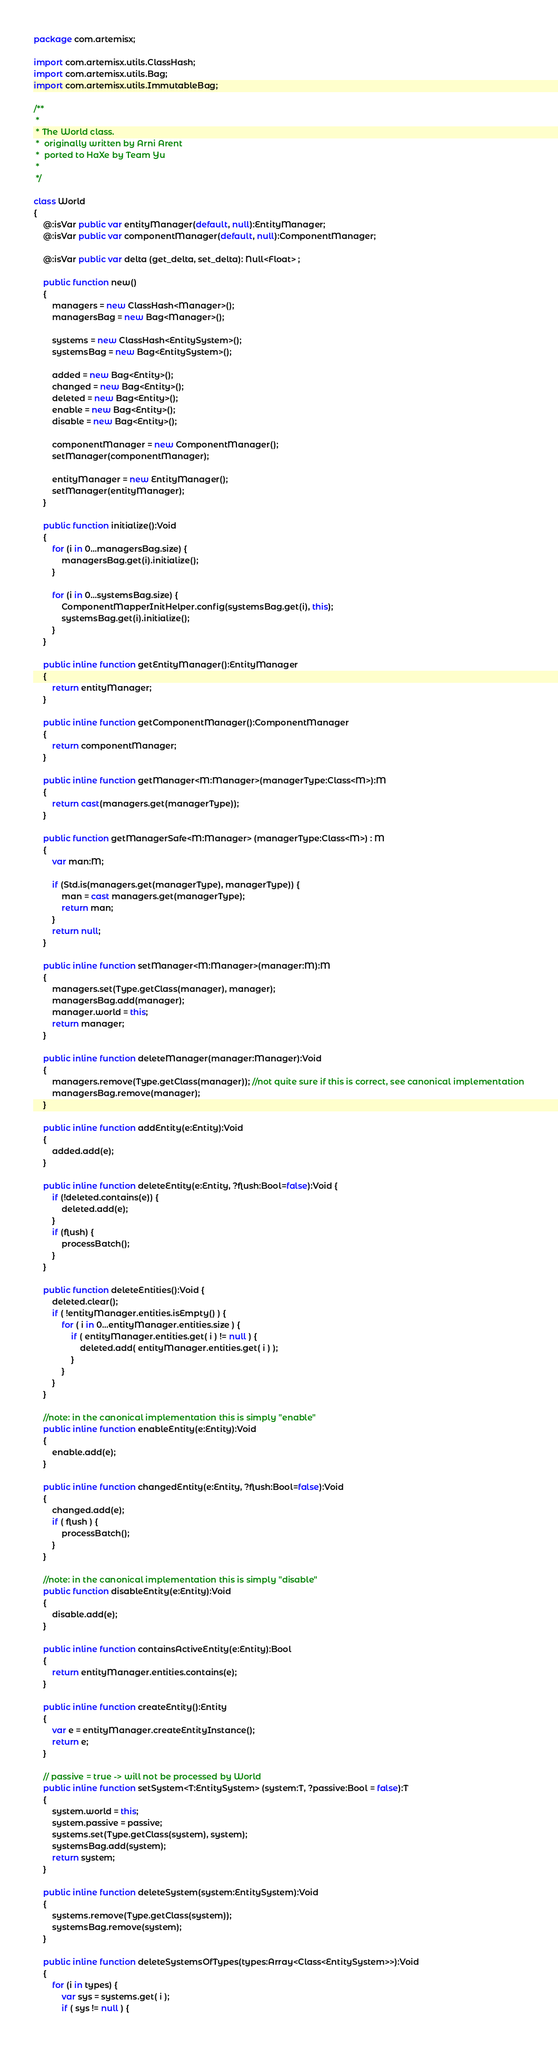Convert code to text. <code><loc_0><loc_0><loc_500><loc_500><_Haxe_>package com.artemisx;

import com.artemisx.utils.ClassHash;
import com.artemisx.utils.Bag;
import com.artemisx.utils.ImmutableBag;

/**
 *
 * The World class.
 *  originally written by Arni Arent
 *  ported to HaXe by Team Yu
 *
 */

class World
{
    @:isVar public var entityManager(default, null):EntityManager;
    @:isVar public var componentManager(default, null):ComponentManager;

    @:isVar public var delta (get_delta, set_delta): Null<Float> ;

    public function new()
    {
        managers = new ClassHash<Manager>();
        managersBag = new Bag<Manager>();

        systems = new ClassHash<EntitySystem>();
        systemsBag = new Bag<EntitySystem>();

        added = new Bag<Entity>();
        changed = new Bag<Entity>();
        deleted = new Bag<Entity>();
        enable = new Bag<Entity>();
        disable = new Bag<Entity>();

        componentManager = new ComponentManager();
        setManager(componentManager);

        entityManager = new EntityManager();
        setManager(entityManager);
    }

    public function initialize():Void
    {
        for (i in 0...managersBag.size) {
            managersBag.get(i).initialize();
        }

        for (i in 0...systemsBag.size) {
            ComponentMapperInitHelper.config(systemsBag.get(i), this);
            systemsBag.get(i).initialize();
        }
    }

    public inline function getEntityManager():EntityManager
    {
        return entityManager;
    }

    public inline function getComponentManager():ComponentManager
    {
        return componentManager;
    }

    public inline function getManager<M:Manager>(managerType:Class<M>):M
    {
        return cast(managers.get(managerType));
    }

    public function getManagerSafe<M:Manager> (managerType:Class<M>) : M
    {
        var man:M;

        if (Std.is(managers.get(managerType), managerType)) {
            man = cast managers.get(managerType);
            return man;
        }
        return null;
    }

    public inline function setManager<M:Manager>(manager:M):M
    {
        managers.set(Type.getClass(manager), manager);
        managersBag.add(manager);
        manager.world = this;
        return manager;
    }

    public inline function deleteManager(manager:Manager):Void
    {
        managers.remove(Type.getClass(manager)); //not quite sure if this is correct, see canonical implementation
        managersBag.remove(manager);
    }

    public inline function addEntity(e:Entity):Void
    {
        added.add(e);
    }

    public inline function deleteEntity(e:Entity, ?flush:Bool=false):Void {
        if (!deleted.contains(e)) {
            deleted.add(e);
        }
        if (flush) {
            processBatch();
        }
    }

    public function deleteEntities():Void {
        deleted.clear();
        if ( !entityManager.entities.isEmpty() ) {
            for ( i in 0...entityManager.entities.size ) {
                if ( entityManager.entities.get( i ) != null ) {
                    deleted.add( entityManager.entities.get( i ) );
                }
            }
        }
    }

    //note: in the canonical implementation this is simply "enable"
    public inline function enableEntity(e:Entity):Void
    {
        enable.add(e);
    }

    public inline function changedEntity(e:Entity, ?flush:Bool=false):Void
    {
        changed.add(e);
        if ( flush ) {
            processBatch();
        }
    }

    //note: in the canonical implementation this is simply "disable"
    public function disableEntity(e:Entity):Void
    {
        disable.add(e);
    }

    public inline function containsActiveEntity(e:Entity):Bool
    {
        return entityManager.entities.contains(e);
    }

    public inline function createEntity():Entity
    {
        var e = entityManager.createEntityInstance();
        return e;
    }

    // passive = true -> will not be processed by World
    public inline function setSystem<T:EntitySystem> (system:T, ?passive:Bool = false):T
    {
        system.world = this;
        system.passive = passive;
        systems.set(Type.getClass(system), system);
        systemsBag.add(system);
        return system;
    }

    public inline function deleteSystem(system:EntitySystem):Void
    {
        systems.remove(Type.getClass(system));
        systemsBag.remove(system);
    }

    public inline function deleteSystemsOfTypes(types:Array<Class<EntitySystem>>):Void
    {
        for (i in types) {
            var sys = systems.get( i );
            if ( sys != null ) {</code> 